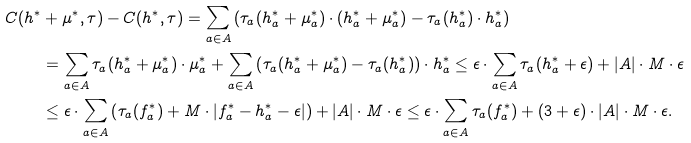<formula> <loc_0><loc_0><loc_500><loc_500>C ( h ^ { * } & + \mu ^ { * } , \tau ) - C ( h ^ { * } , \tau ) = \sum _ { a \in A } \left ( \tau _ { a } ( h ^ { * } _ { a } + \mu _ { a } ^ { * } ) \cdot ( h _ { a } ^ { * } + \mu _ { a } ^ { * } ) - \tau _ { a } ( h ^ { * } _ { a } ) \cdot h _ { a } ^ { * } \right ) \\ & = \sum _ { a \in A } \tau _ { a } ( h ^ { * } _ { a } + \mu _ { a } ^ { * } ) \cdot \mu _ { a } ^ { * } + \sum _ { a \in A } \left ( \tau _ { a } ( h ^ { * } _ { a } + \mu _ { a } ^ { * } ) - \tau _ { a } ( h _ { a } ^ { * } ) \right ) \cdot h _ { a } ^ { * } \leq \epsilon \cdot \sum _ { a \in A } \tau _ { a } ( h ^ { * } _ { a } + \epsilon ) + | A | \cdot M \cdot \epsilon \\ & \leq \epsilon \cdot \sum _ { a \in A } \left ( \tau _ { a } ( f ^ { * } _ { a } ) + M \cdot | f _ { a } ^ { * } - h _ { a } ^ { * } - \epsilon | \right ) + | A | \cdot M \cdot \epsilon \leq \epsilon \cdot \sum _ { a \in A } \tau _ { a } ( f _ { a } ^ { * } ) + ( 3 + \epsilon ) \cdot | A | \cdot M \cdot \epsilon .</formula> 